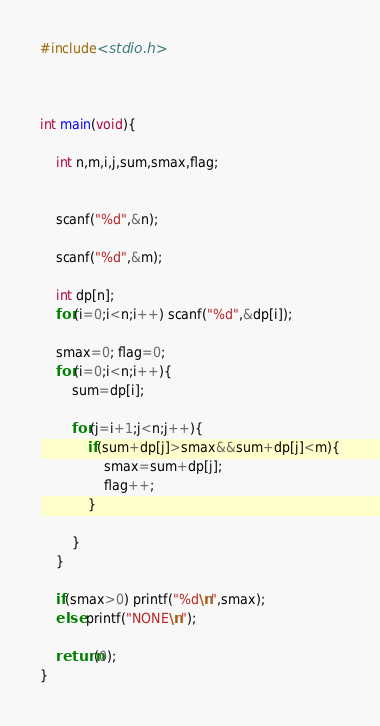<code> <loc_0><loc_0><loc_500><loc_500><_C_>#include<stdio.h>



int main(void){

    int n,m,i,j,sum,smax,flag;


    scanf("%d",&n);

    scanf("%d",&m);

    int dp[n];
    for(i=0;i<n;i++) scanf("%d",&dp[i]);

    smax=0; flag=0;
    for(i=0;i<n;i++){
        sum=dp[i];

        for(j=i+1;j<n;j++){
            if(sum+dp[j]>smax&&sum+dp[j]<m){
                smax=sum+dp[j];
                flag++;
            }

        }
    }

    if(smax>0) printf("%d\n",smax);
    else printf("NONE\n");

    return(0);
}
</code> 